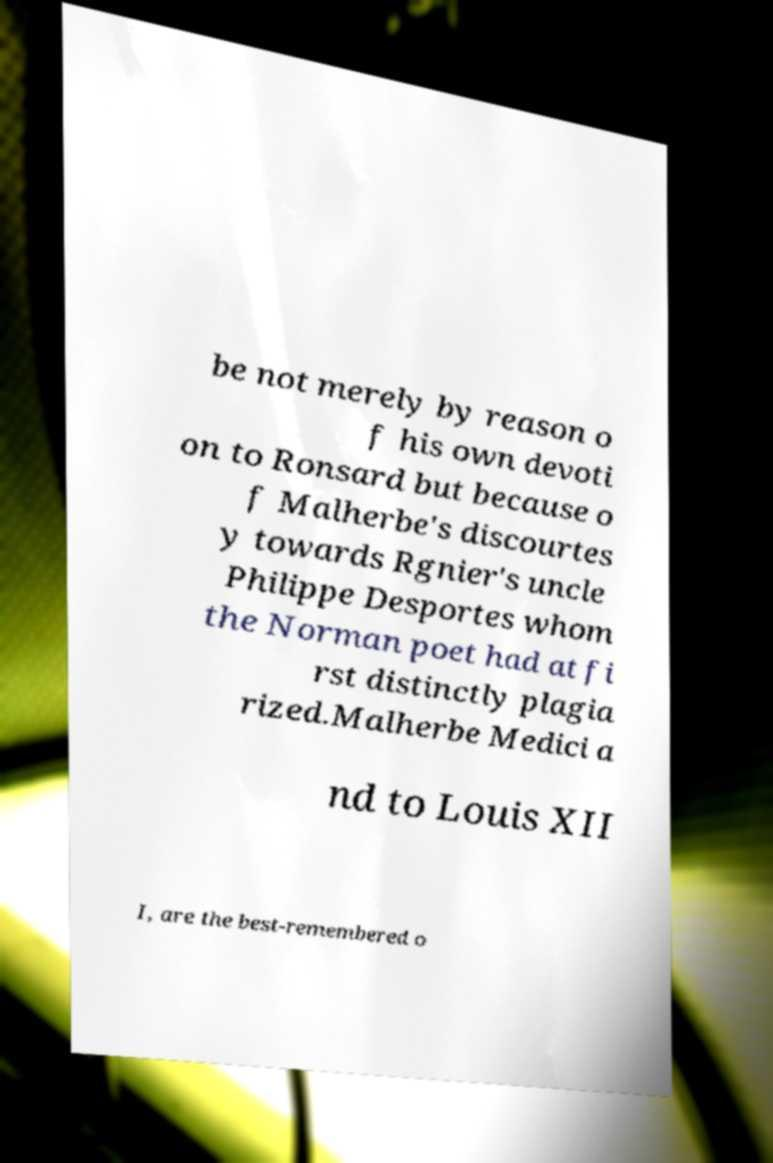For documentation purposes, I need the text within this image transcribed. Could you provide that? be not merely by reason o f his own devoti on to Ronsard but because o f Malherbe's discourtes y towards Rgnier's uncle Philippe Desportes whom the Norman poet had at fi rst distinctly plagia rized.Malherbe Medici a nd to Louis XII I, are the best-remembered o 